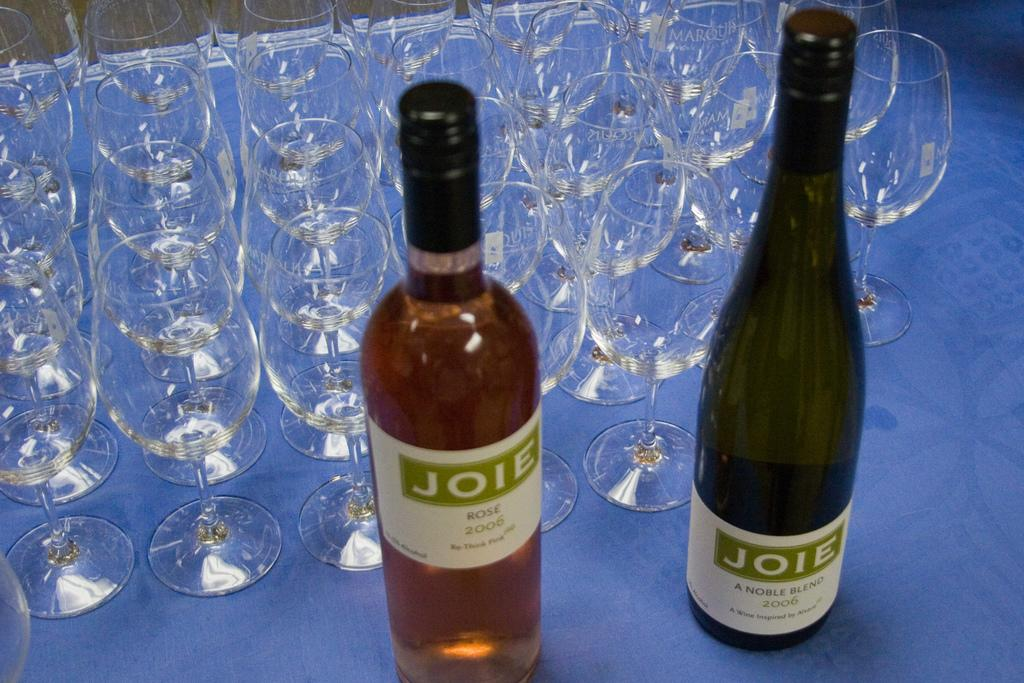<image>
Offer a succinct explanation of the picture presented. two wine bottles branded with a JOIE logo 